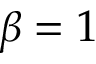<formula> <loc_0><loc_0><loc_500><loc_500>\beta = 1</formula> 